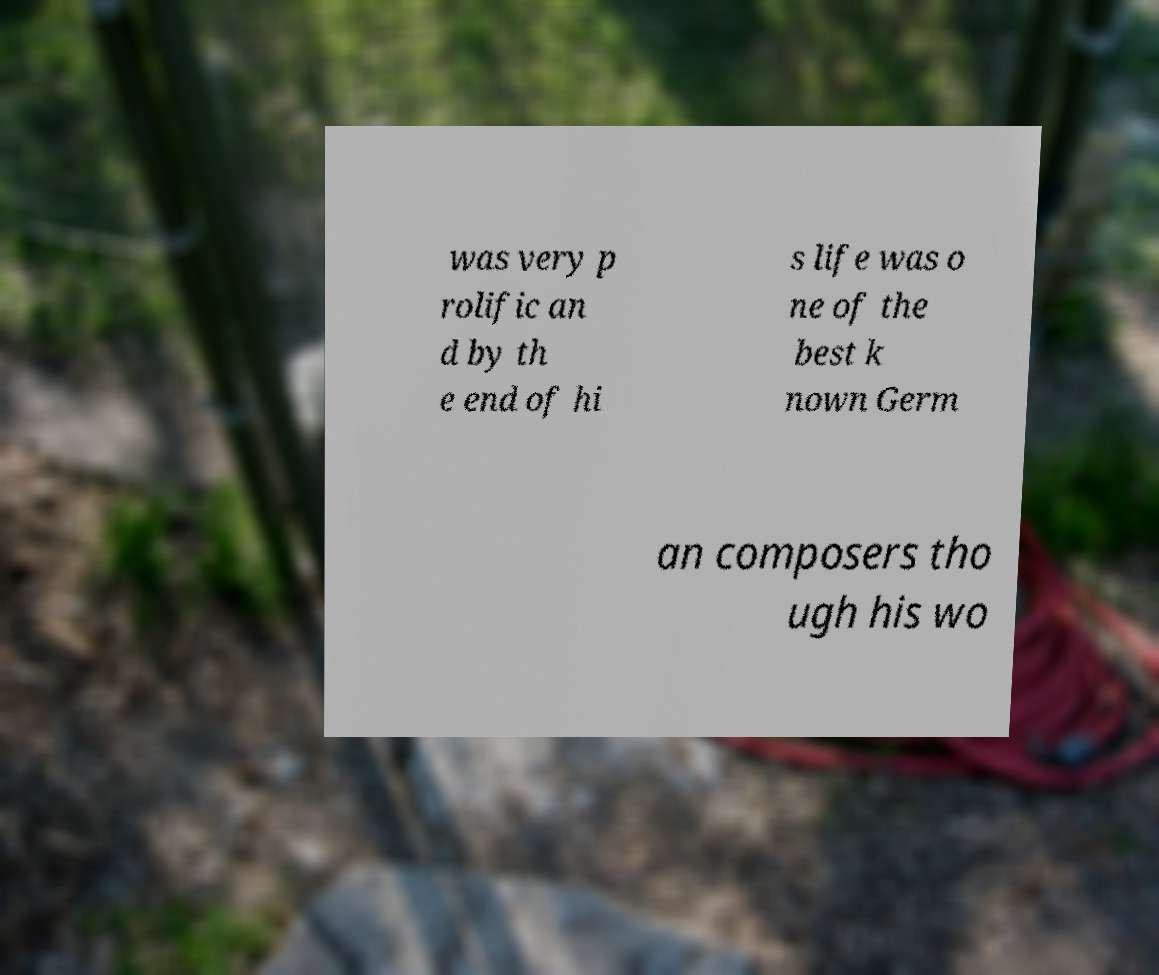Could you assist in decoding the text presented in this image and type it out clearly? was very p rolific an d by th e end of hi s life was o ne of the best k nown Germ an composers tho ugh his wo 